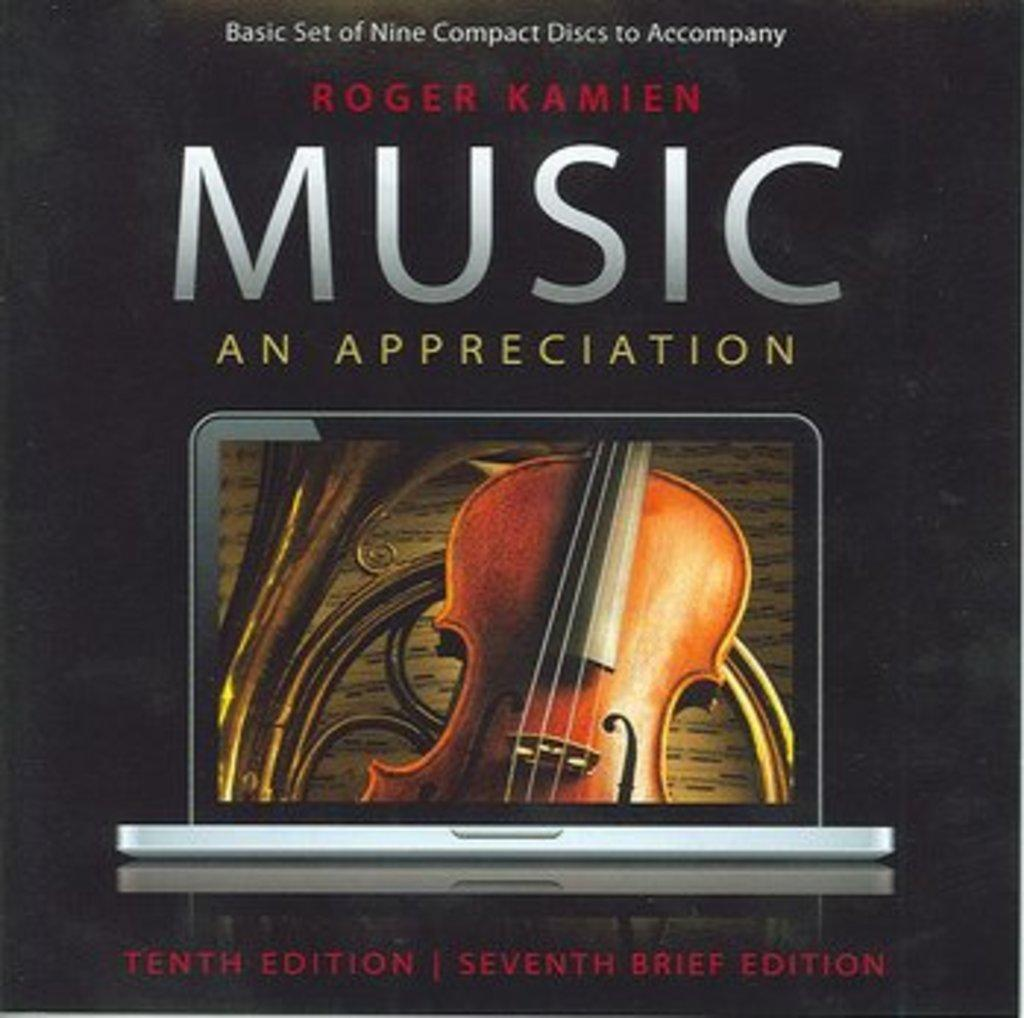<image>
Write a terse but informative summary of the picture. Album cover with a violin on it called "Music An Appreciation". 